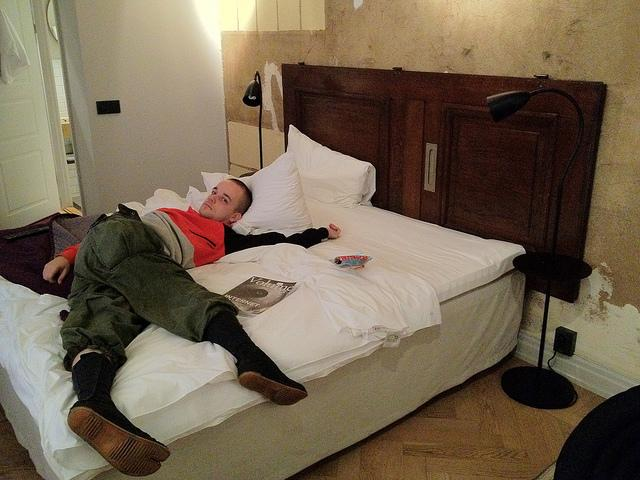What is next to the bed? Please explain your reasoning. lamp. A light is next to the bed. 